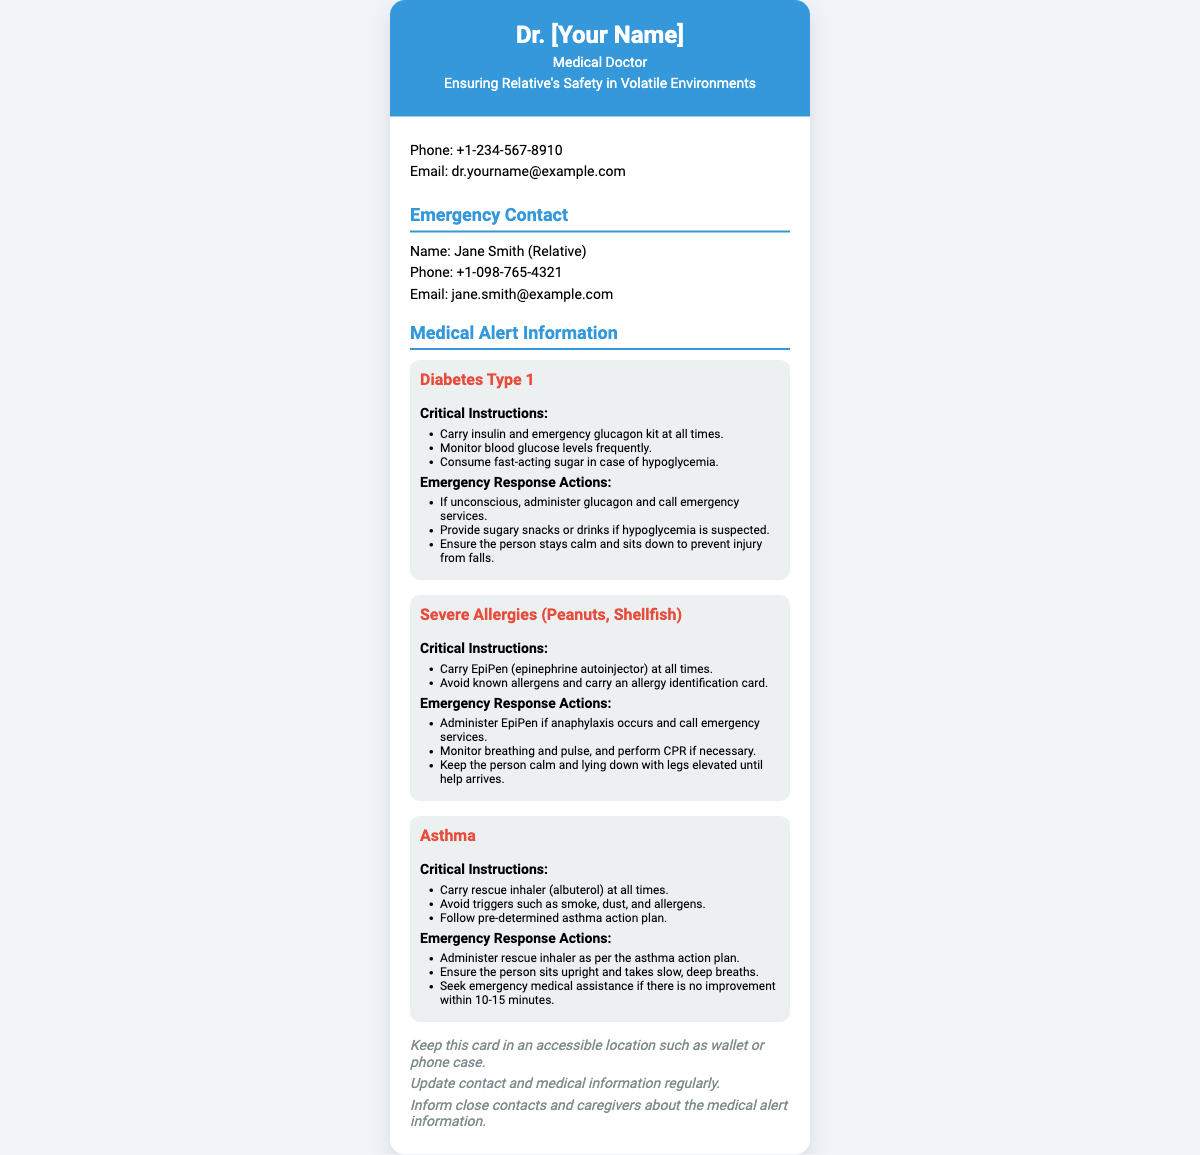What is the doctor's name? The doctor's name is present in the header of the card, indicated as "Dr. [Your Name]".
Answer: Dr. [Your Name] What is the phone number of the doctor? The doctor's contact phone number is listed in the contact information section.
Answer: +1-234-567-8910 Who is the emergency contact? The emergency contact's name is provided in the emergency contact section.
Answer: Jane Smith What is one critical instruction for managing diabetes? A critical instruction for managing diabetes is found in the medical condition section related to diabetes.
Answer: Carry insulin and emergency glucagon kit at all times What should be done if someone goes unconscious due to diabetes? The emergency response action for unconsciousness related to diabetes is mentioned in the document.
Answer: Administer glucagon and call emergency services How many medical conditions are detailed in this card? The card lists the number of medical conditions addressed, specifically under the "Medical Alert Information" section.
Answer: Three What action should be taken for an asthma attack? Emergency response actions for asthma are specified, with a focus on immediate measures to take during an attack.
Answer: Administer rescue inhaler as per the asthma action plan What type of allergies does the document mention? The specific type of allergies is noted under the medical conditions section with a mention of specific allergens.
Answer: Peanuts, Shellfish Where should this card be kept? Additional notes specify the proper storage location for the card in order to ensure accessibility.
Answer: Wallet or phone case 